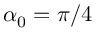<formula> <loc_0><loc_0><loc_500><loc_500>\alpha _ { 0 } = \pi / 4</formula> 